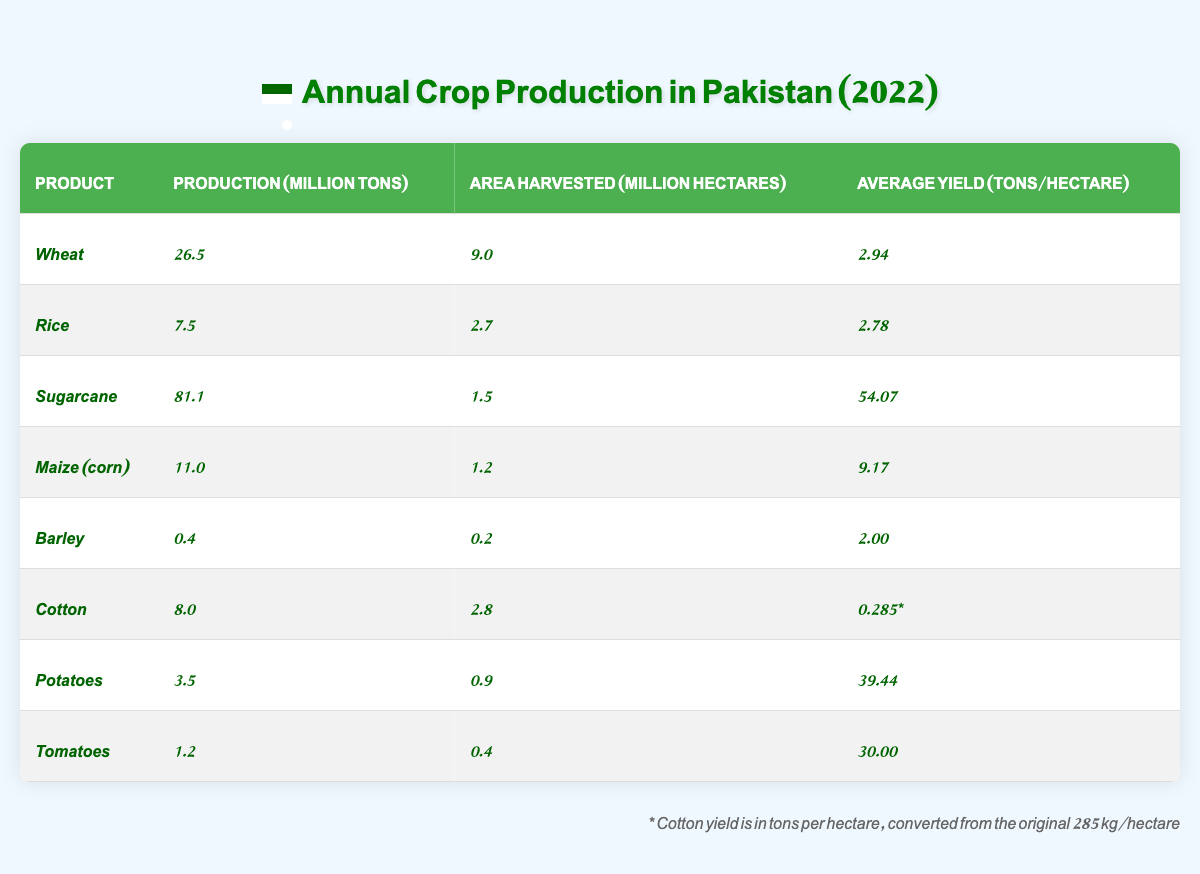What is the total production of wheat and rice combined? The production of wheat is 26.5 million tons, and the production of rice is 7.5 million tons. To find the total, we add these two amounts: 26.5 + 7.5 = 34.0 million tons.
Answer: 34.0 million tons Which product has the highest average yield per hectare? Looking at the average yield per hectare for each product, Sugarcane has the highest yield at 54.07 tons per hectare.
Answer: Sugarcane How much area was harvested for cotton? The area harvested for cotton is mentioned as 2.8 million hectares.
Answer: 2.8 million hectares Is the average yield of barley greater than 3 tons per hectare? The average yield of barley is 2.00 tons per hectare, which is less than 3 tons. Therefore, the statement is false.
Answer: No What is the difference in production between sugarcane and potatoes? The production of sugarcane is 81.1 million tons and for potatoes is 3.5 million tons. The difference is calculated as 81.1 - 3.5 = 77.6 million tons.
Answer: 77.6 million tons What is the total area harvested for all crops listed? The areas harvested are: Wheat (9.0), Rice (2.7), Sugarcane (1.5), Maize (1.2), Barley (0.2), Cotton (2.8), Potatoes (0.9), and Tomatoes (0.4). Adding these together: 9.0 + 2.7 + 1.5 + 1.2 + 0.2 + 2.8 + 0.9 + 0.4 = 18.7 million hectares.
Answer: 18.7 million hectares Which crop had the lowest production in 2022? By checking the production values in the table, Barley has the lowest production at 0.4 million tons.
Answer: Barley What is the average yield of rice compared to maize? The average yield for rice is 2.78 tons per hectare and for maize is 9.17 tons per hectare. Therefore, maize has a higher yield than rice. The average yield of maize is greater.
Answer: Maize If cotton was measured in kilograms per hectare, what is its yield in tons per hectare? The yield of cotton is given as 285 kg/hectare. Since 1 ton = 1000 kg, we convert by dividing: 285 / 1000 = 0.285 tons/hectare.
Answer: 0.285 tons/hectare How much total production of all products except sugarcane? The total production values excluding sugarcane would be: Wheat (26.5), Rice (7.5), Maize (11.0), Barley (0.4), Cotton (8.0), Potatoes (3.5), and Tomatoes (1.2). Adding these gives: 26.5 + 7.5 + 11.0 + 0.4 + 8.0 + 3.5 + 1.2 = 58.1 million tons.
Answer: 58.1 million tons What percentage of total production does wheat represent? The total production of all crops is 81.1 + 26.5 + 7.5 + 11.0 + 0.4 + 8.0 + 3.5 + 1.2 = 139.2 million tons. The percentage for wheat is (26.5 / 139.2) * 100 = approximately 19.0%.
Answer: Approximately 19.0% 